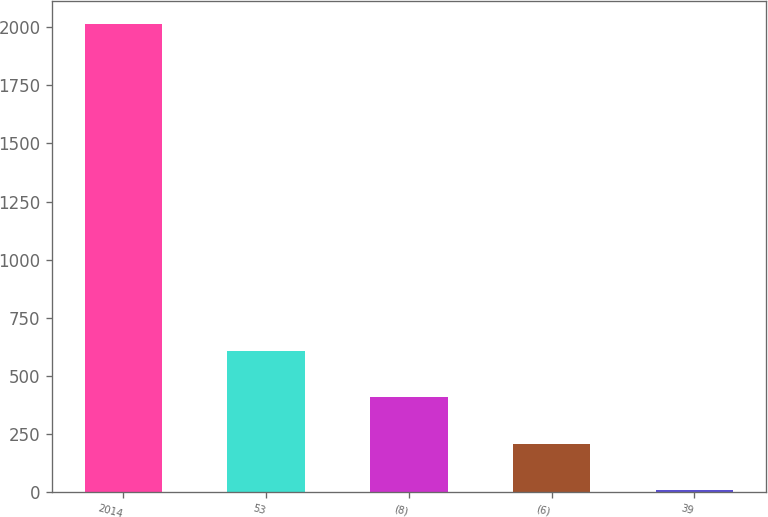Convert chart to OTSL. <chart><loc_0><loc_0><loc_500><loc_500><bar_chart><fcel>2014<fcel>53<fcel>(8)<fcel>(6)<fcel>39<nl><fcel>2012<fcel>608.5<fcel>408<fcel>207.5<fcel>7<nl></chart> 